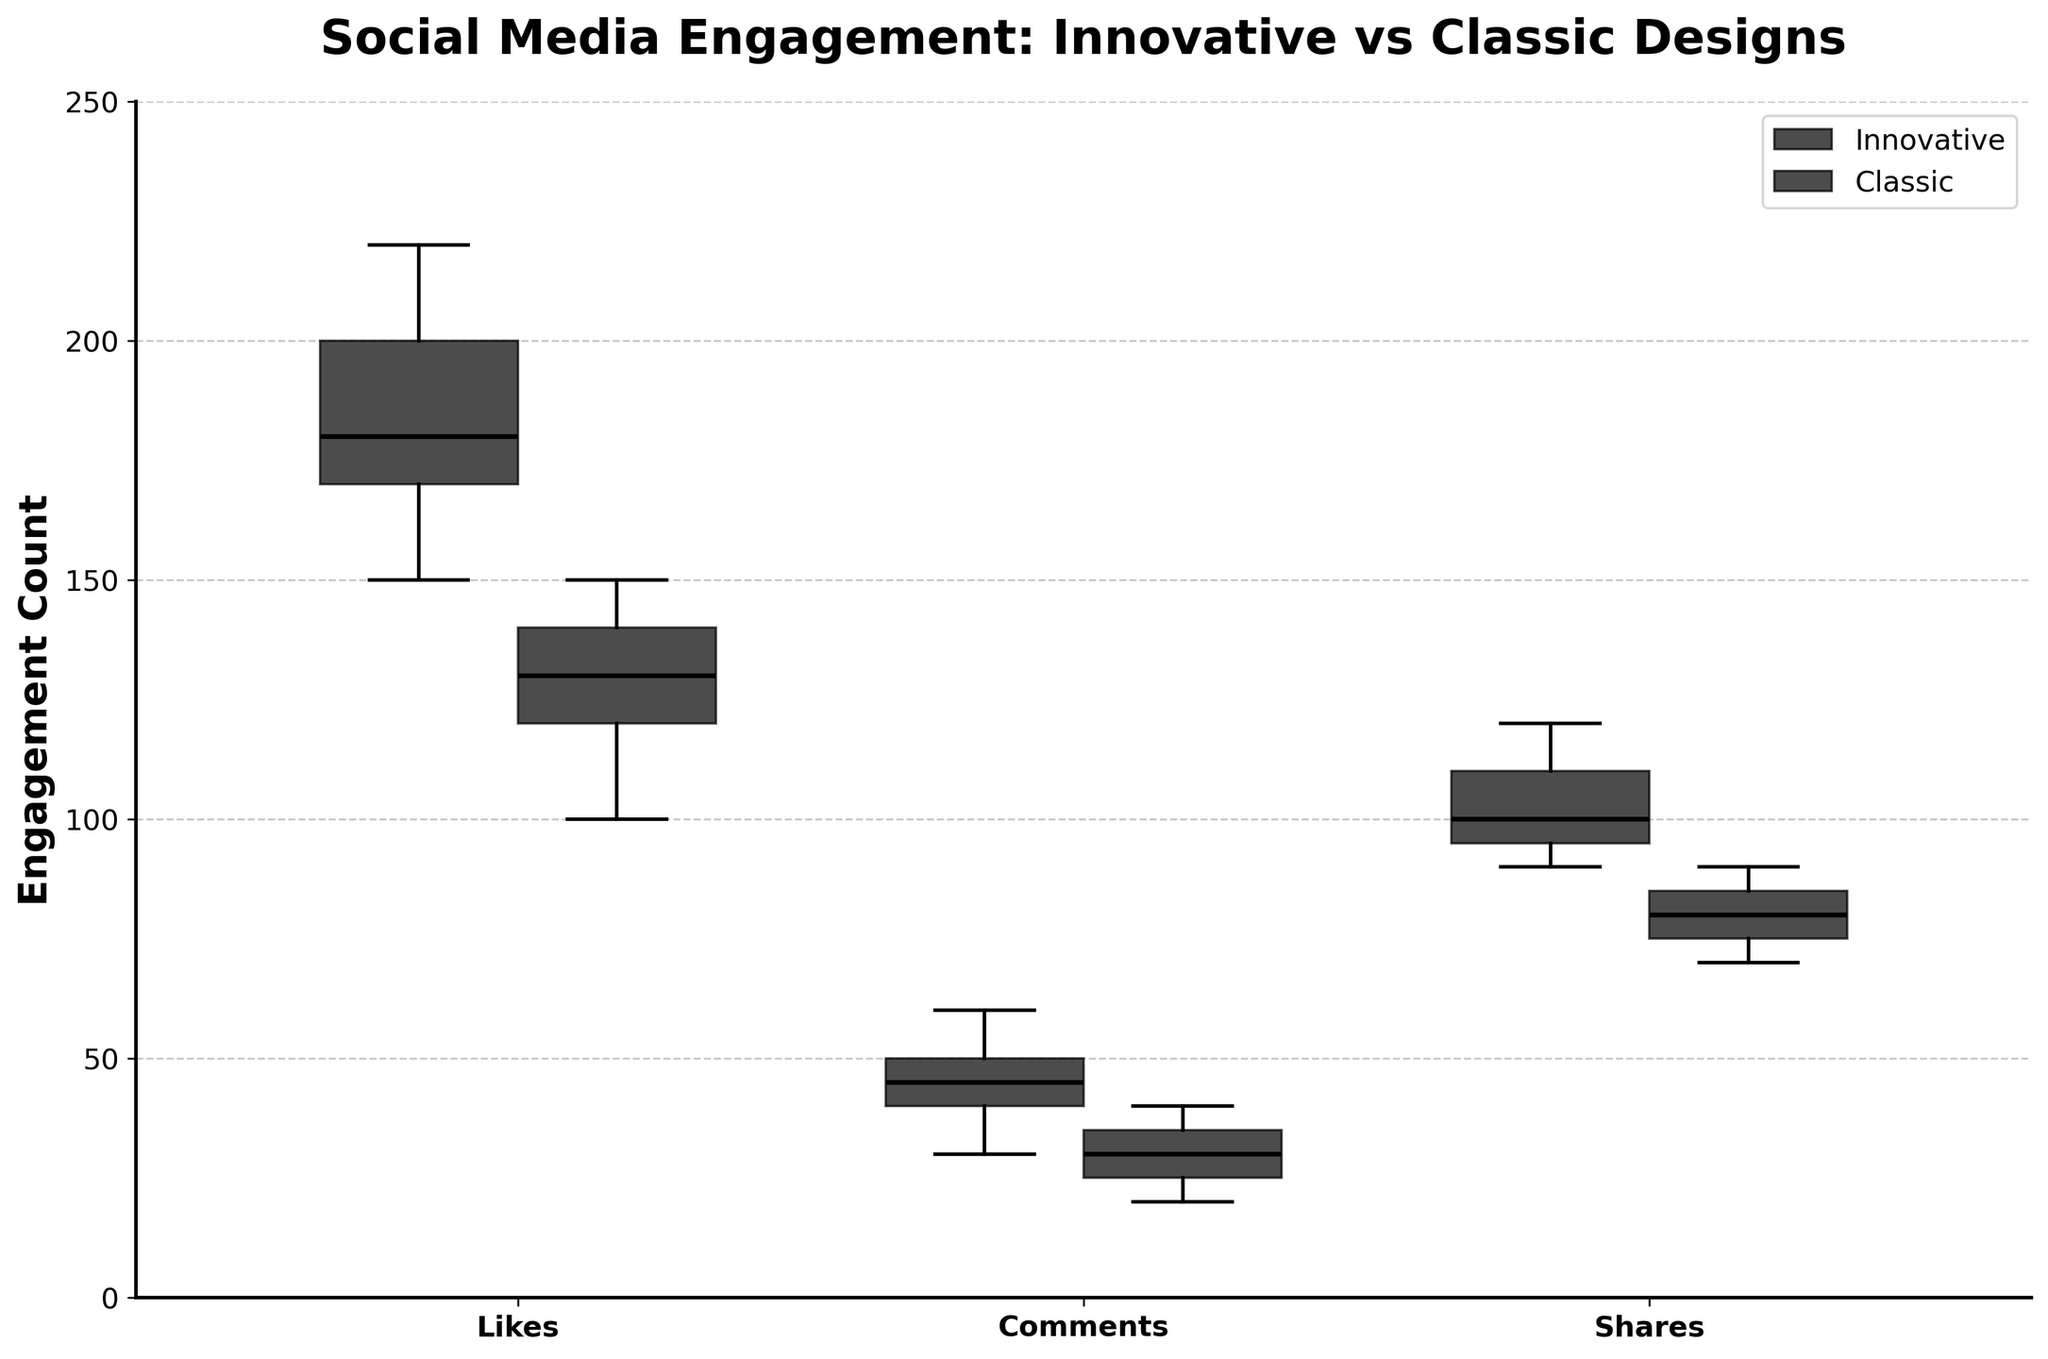What's the title of the figure? The title of a figure is typically located at the top and provides a summary of what the figure is about. For this plot, the title is placed prominently.
Answer: Social Media Engagement: Innovative vs Classic Designs What does the y-axis represent? The y-axis usually displays the metric being measured. In this plot, it represents the count of social media engagements. This is evident from the label provided on the y-axis.
Answer: Engagement Count Which design gets higher median likes? To find the median likes, observe the middle line in each box for the "Likes" metric. The median for the "Innovative" design is higher than the "Classic" design.
Answer: Innovative Which design has a wider range of shares? The range can be determined by looking at the whiskers' length, representing the spread from the lowest to the highest share count. The "Innovative" design has wider whiskers, indicating a wider range.
Answer: Innovative Are there any outliers for the comments metric? Outliers in a box plot are typically shown as individual points outside the whiskers. For the "Comments" metric, there are no visible points outside the whiskers.
Answer: No For which metric do innovative designs have the highest engagement? Observing the height of the boxes and whiskers for the "Innovative" design across all metrics, "Likes" have the highest engagement as the top few lines (whiskers) and boxes are higher than others.
Answer: Likes What is the median number of comments for classic designs? Locate the "Comments" metric, and then find the horizontal line inside the box for the "Classic" design, which represents the median. This line appears close to 30.
Answer: 30 Which group has a lower minimum value in the "Shares" metric? The minimum value is indicated by the bottom whisker of each box. Comparing the whiskers for "Shares," the "Classic" design’s bottom whisker is lower.
Answer: Classic How do the interquartile ranges (IQR) of likes compare between the two designs? The IQR is the range of the middle 50% of the data, represented by the height of the box. The IQR for "Innovative" design is larger since the box is taller compared to the "Classic" design.
Answer: Innovative has a larger IQR Which metric shows the most overlap between innovative and classic designs? Overlap is indicated by how much the boxes and whiskers of the two designs intersect. The "Comments" metric shows the most overlap as the boxes and whiskers from both overlap the most.
Answer: Comments 